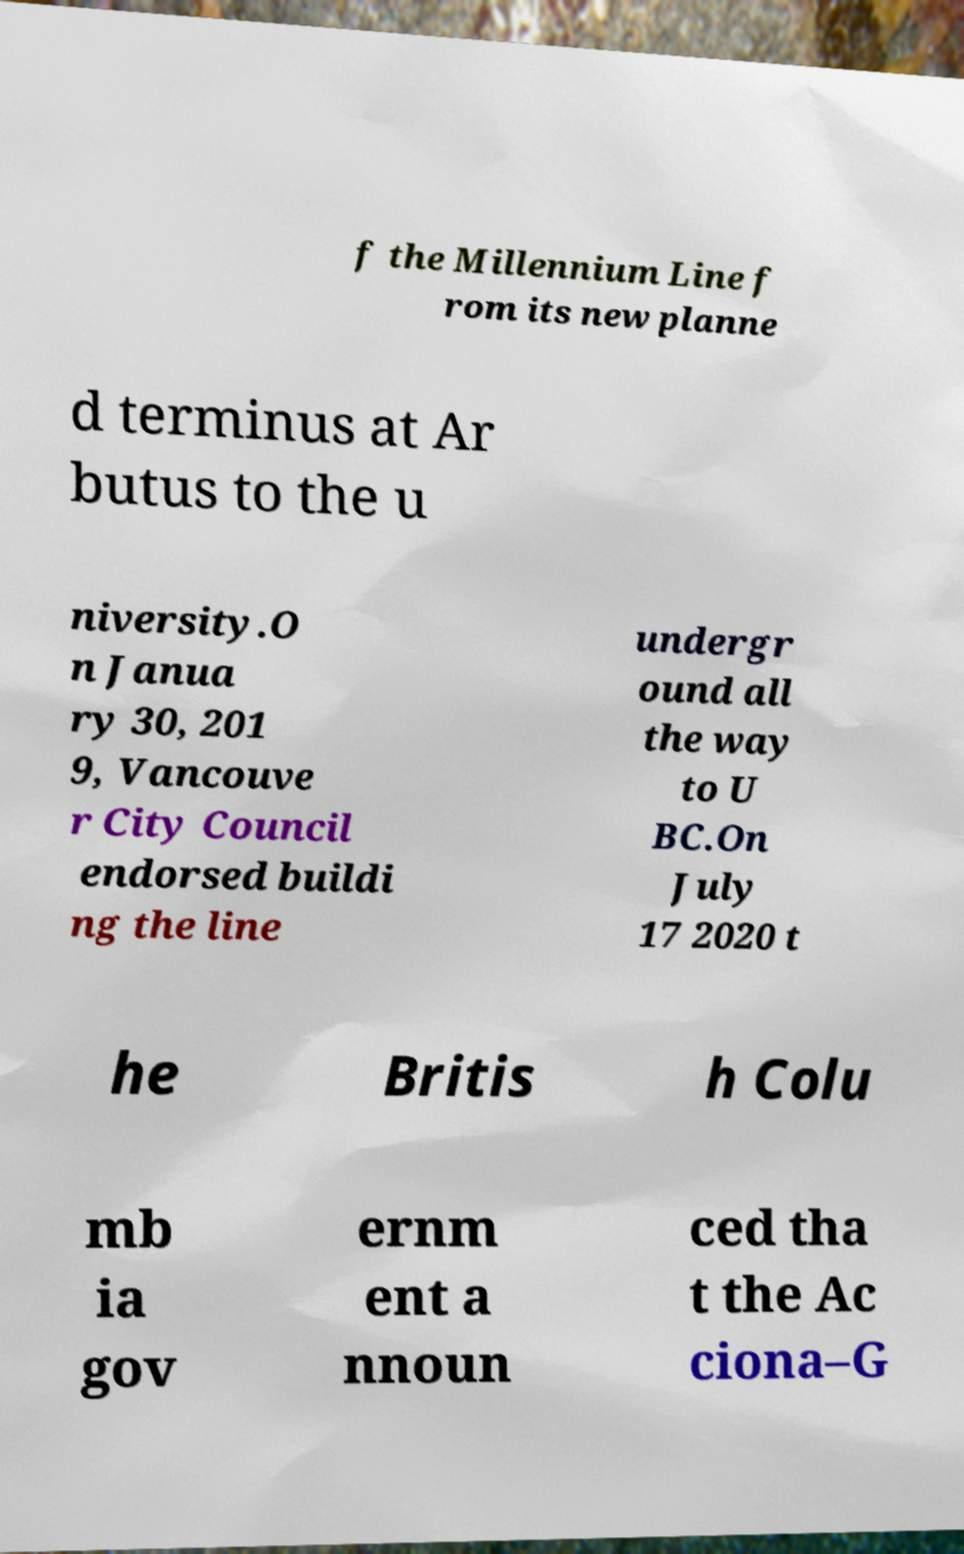There's text embedded in this image that I need extracted. Can you transcribe it verbatim? f the Millennium Line f rom its new planne d terminus at Ar butus to the u niversity.O n Janua ry 30, 201 9, Vancouve r City Council endorsed buildi ng the line undergr ound all the way to U BC.On July 17 2020 t he Britis h Colu mb ia gov ernm ent a nnoun ced tha t the Ac ciona–G 